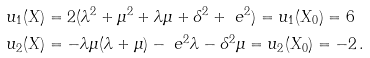Convert formula to latex. <formula><loc_0><loc_0><loc_500><loc_500>u _ { 1 } ( X ) & = 2 ( \lambda ^ { 2 } + \mu ^ { 2 } + \lambda \mu + \delta ^ { 2 } + \ e ^ { 2 } ) = u _ { 1 } ( X _ { 0 } ) = 6 \\ u _ { 2 } ( X ) & = - \lambda \mu ( \lambda + \mu ) - \ e ^ { 2 } \lambda - \delta ^ { 2 } \mu = u _ { 2 } ( X _ { 0 } ) = - 2 \, .</formula> 